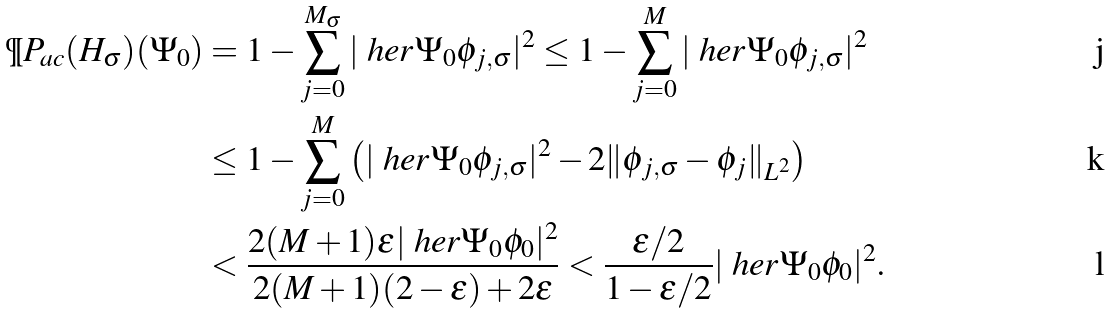Convert formula to latex. <formula><loc_0><loc_0><loc_500><loc_500>\P P _ { \text {ac} } ( H _ { \sigma } ) ( \Psi _ { 0 } ) & = 1 - \sum _ { j = 0 } ^ { M _ { \sigma } } | \ h e r { \Psi _ { 0 } } { \phi _ { j , \sigma } } | ^ { 2 } \leq 1 - \sum _ { j = 0 } ^ { M } | \ h e r { \Psi _ { 0 } } { \phi _ { j , \sigma } } | ^ { 2 } \\ & \leq 1 - \sum _ { j = 0 } ^ { M } \left ( | \ h e r { \Psi _ { 0 } } { \phi _ { j , \sigma } } | ^ { 2 } - 2 \| \phi _ { j , \sigma } - \phi _ { j } \| _ { L ^ { 2 } } \right ) \\ & < \frac { 2 ( M + 1 ) \epsilon | \ h e r { \Psi _ { 0 } } { \phi _ { 0 } } | ^ { 2 } } { 2 ( M + 1 ) ( 2 - \epsilon ) + 2 \epsilon } < \frac { \epsilon / 2 } { 1 - \epsilon / 2 } | \ h e r { \Psi _ { 0 } } { \phi _ { 0 } } | ^ { 2 } .</formula> 